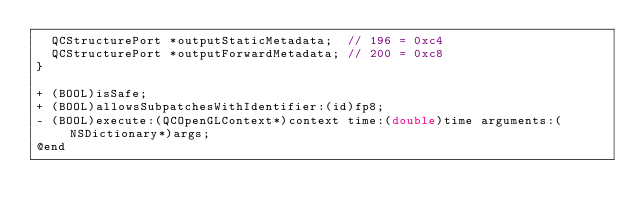Convert code to text. <code><loc_0><loc_0><loc_500><loc_500><_C_>	QCStructurePort *outputStaticMetadata;	// 196 = 0xc4
	QCStructurePort *outputForwardMetadata;	// 200 = 0xc8
}

+ (BOOL)isSafe;
+ (BOOL)allowsSubpatchesWithIdentifier:(id)fp8;
- (BOOL)execute:(QCOpenGLContext*)context time:(double)time arguments:(NSDictionary*)args;
@end
</code> 